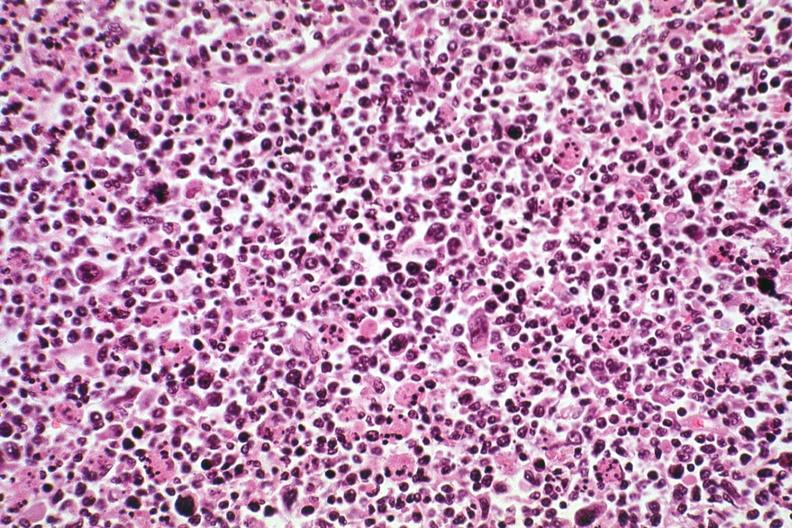does previous slide from this case show pleomorphic see other slides this case?
Answer the question using a single word or phrase. No 